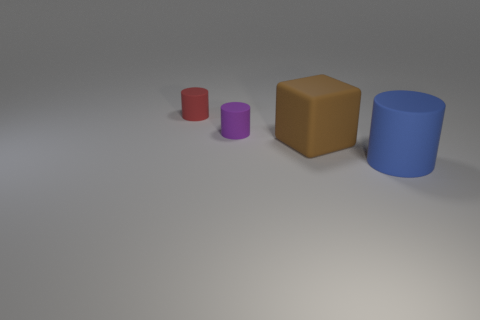Add 2 rubber cubes. How many objects exist? 6 Subtract all cylinders. How many objects are left? 1 Subtract all big cylinders. Subtract all brown cubes. How many objects are left? 2 Add 1 brown rubber things. How many brown rubber things are left? 2 Add 4 small yellow shiny things. How many small yellow shiny things exist? 4 Subtract 1 red cylinders. How many objects are left? 3 